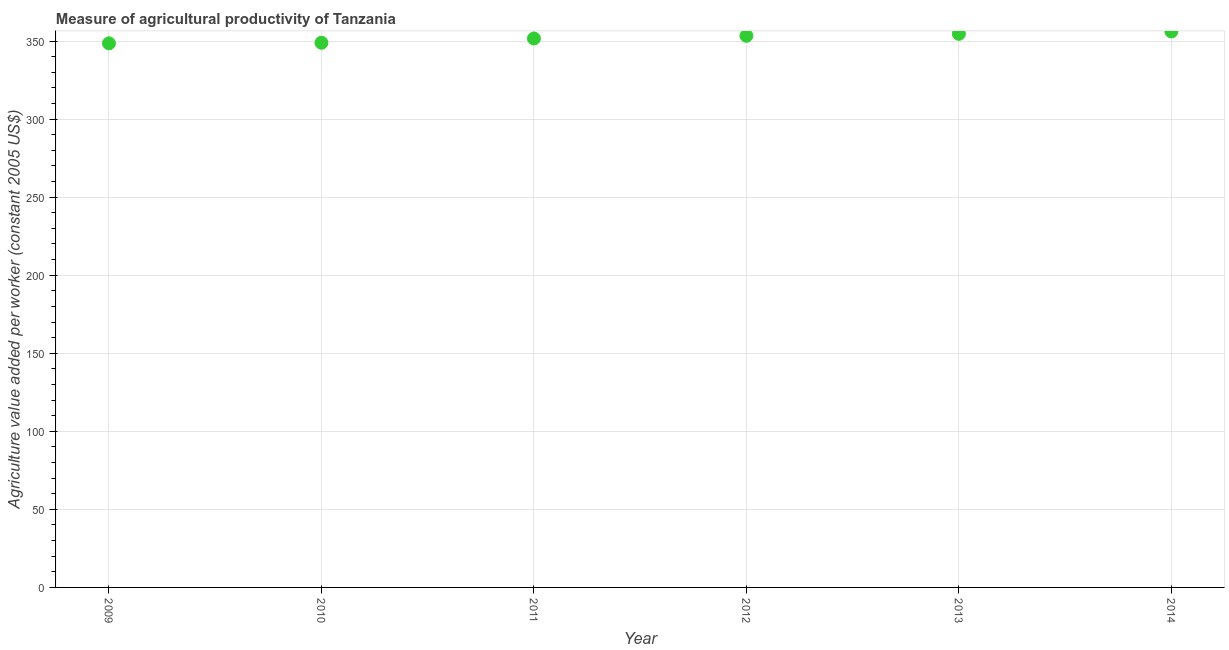What is the agriculture value added per worker in 2010?
Make the answer very short. 348.9. Across all years, what is the maximum agriculture value added per worker?
Make the answer very short. 356.18. Across all years, what is the minimum agriculture value added per worker?
Your answer should be very brief. 348.54. In which year was the agriculture value added per worker maximum?
Offer a terse response. 2014. In which year was the agriculture value added per worker minimum?
Provide a succinct answer. 2009. What is the sum of the agriculture value added per worker?
Offer a very short reply. 2113.26. What is the difference between the agriculture value added per worker in 2011 and 2012?
Your response must be concise. -1.72. What is the average agriculture value added per worker per year?
Provide a short and direct response. 352.21. What is the median agriculture value added per worker?
Your answer should be very brief. 352.5. In how many years, is the agriculture value added per worker greater than 210 US$?
Your answer should be compact. 6. Do a majority of the years between 2009 and 2012 (inclusive) have agriculture value added per worker greater than 320 US$?
Your answer should be very brief. Yes. What is the ratio of the agriculture value added per worker in 2009 to that in 2012?
Give a very brief answer. 0.99. Is the difference between the agriculture value added per worker in 2010 and 2012 greater than the difference between any two years?
Give a very brief answer. No. What is the difference between the highest and the second highest agriculture value added per worker?
Offer a terse response. 1.55. Is the sum of the agriculture value added per worker in 2009 and 2014 greater than the maximum agriculture value added per worker across all years?
Provide a succinct answer. Yes. What is the difference between the highest and the lowest agriculture value added per worker?
Your answer should be very brief. 7.64. In how many years, is the agriculture value added per worker greater than the average agriculture value added per worker taken over all years?
Your answer should be compact. 3. How many dotlines are there?
Offer a terse response. 1. How many years are there in the graph?
Your answer should be compact. 6. Are the values on the major ticks of Y-axis written in scientific E-notation?
Your answer should be very brief. No. Does the graph contain any zero values?
Provide a succinct answer. No. Does the graph contain grids?
Ensure brevity in your answer.  Yes. What is the title of the graph?
Offer a terse response. Measure of agricultural productivity of Tanzania. What is the label or title of the X-axis?
Keep it short and to the point. Year. What is the label or title of the Y-axis?
Provide a succinct answer. Agriculture value added per worker (constant 2005 US$). What is the Agriculture value added per worker (constant 2005 US$) in 2009?
Provide a succinct answer. 348.54. What is the Agriculture value added per worker (constant 2005 US$) in 2010?
Keep it short and to the point. 348.9. What is the Agriculture value added per worker (constant 2005 US$) in 2011?
Provide a short and direct response. 351.65. What is the Agriculture value added per worker (constant 2005 US$) in 2012?
Offer a terse response. 353.36. What is the Agriculture value added per worker (constant 2005 US$) in 2013?
Your answer should be very brief. 354.63. What is the Agriculture value added per worker (constant 2005 US$) in 2014?
Give a very brief answer. 356.18. What is the difference between the Agriculture value added per worker (constant 2005 US$) in 2009 and 2010?
Ensure brevity in your answer.  -0.36. What is the difference between the Agriculture value added per worker (constant 2005 US$) in 2009 and 2011?
Your response must be concise. -3.1. What is the difference between the Agriculture value added per worker (constant 2005 US$) in 2009 and 2012?
Your answer should be compact. -4.82. What is the difference between the Agriculture value added per worker (constant 2005 US$) in 2009 and 2013?
Provide a succinct answer. -6.09. What is the difference between the Agriculture value added per worker (constant 2005 US$) in 2009 and 2014?
Your answer should be very brief. -7.64. What is the difference between the Agriculture value added per worker (constant 2005 US$) in 2010 and 2011?
Offer a very short reply. -2.74. What is the difference between the Agriculture value added per worker (constant 2005 US$) in 2010 and 2012?
Keep it short and to the point. -4.46. What is the difference between the Agriculture value added per worker (constant 2005 US$) in 2010 and 2013?
Provide a succinct answer. -5.73. What is the difference between the Agriculture value added per worker (constant 2005 US$) in 2010 and 2014?
Provide a short and direct response. -7.28. What is the difference between the Agriculture value added per worker (constant 2005 US$) in 2011 and 2012?
Offer a very short reply. -1.72. What is the difference between the Agriculture value added per worker (constant 2005 US$) in 2011 and 2013?
Ensure brevity in your answer.  -2.98. What is the difference between the Agriculture value added per worker (constant 2005 US$) in 2011 and 2014?
Provide a succinct answer. -4.53. What is the difference between the Agriculture value added per worker (constant 2005 US$) in 2012 and 2013?
Your answer should be very brief. -1.27. What is the difference between the Agriculture value added per worker (constant 2005 US$) in 2012 and 2014?
Offer a terse response. -2.82. What is the difference between the Agriculture value added per worker (constant 2005 US$) in 2013 and 2014?
Provide a short and direct response. -1.55. What is the ratio of the Agriculture value added per worker (constant 2005 US$) in 2009 to that in 2011?
Ensure brevity in your answer.  0.99. What is the ratio of the Agriculture value added per worker (constant 2005 US$) in 2009 to that in 2012?
Offer a very short reply. 0.99. What is the ratio of the Agriculture value added per worker (constant 2005 US$) in 2010 to that in 2011?
Give a very brief answer. 0.99. What is the ratio of the Agriculture value added per worker (constant 2005 US$) in 2010 to that in 2013?
Your response must be concise. 0.98. What is the ratio of the Agriculture value added per worker (constant 2005 US$) in 2011 to that in 2012?
Offer a terse response. 0.99. What is the ratio of the Agriculture value added per worker (constant 2005 US$) in 2011 to that in 2014?
Your response must be concise. 0.99. What is the ratio of the Agriculture value added per worker (constant 2005 US$) in 2012 to that in 2013?
Offer a very short reply. 1. What is the ratio of the Agriculture value added per worker (constant 2005 US$) in 2012 to that in 2014?
Offer a terse response. 0.99. 